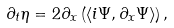<formula> <loc_0><loc_0><loc_500><loc_500>\partial _ { t } \eta = 2 \partial _ { x } \left ( \langle i \Psi , \partial _ { x } \Psi \rangle \right ) ,</formula> 